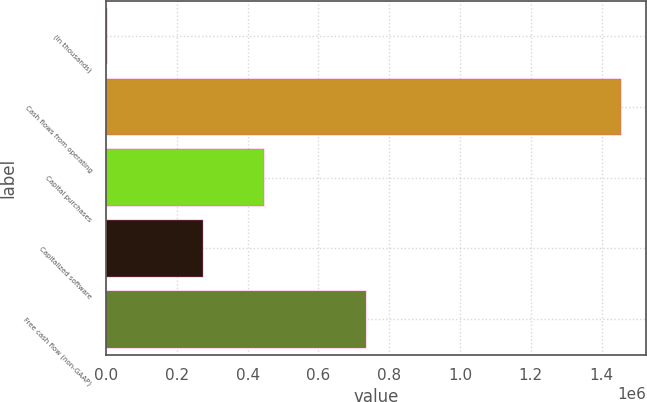Convert chart to OTSL. <chart><loc_0><loc_0><loc_500><loc_500><bar_chart><fcel>(In thousands)<fcel>Cash flows from operating<fcel>Capital purchases<fcel>Capitalized software<fcel>Free cash flow (non-GAAP)<nl><fcel>2018<fcel>1.45401e+06<fcel>446928<fcel>273693<fcel>733388<nl></chart> 